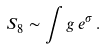Convert formula to latex. <formula><loc_0><loc_0><loc_500><loc_500>S _ { 8 } & \sim \int g \, e ^ { \sigma } \, .</formula> 